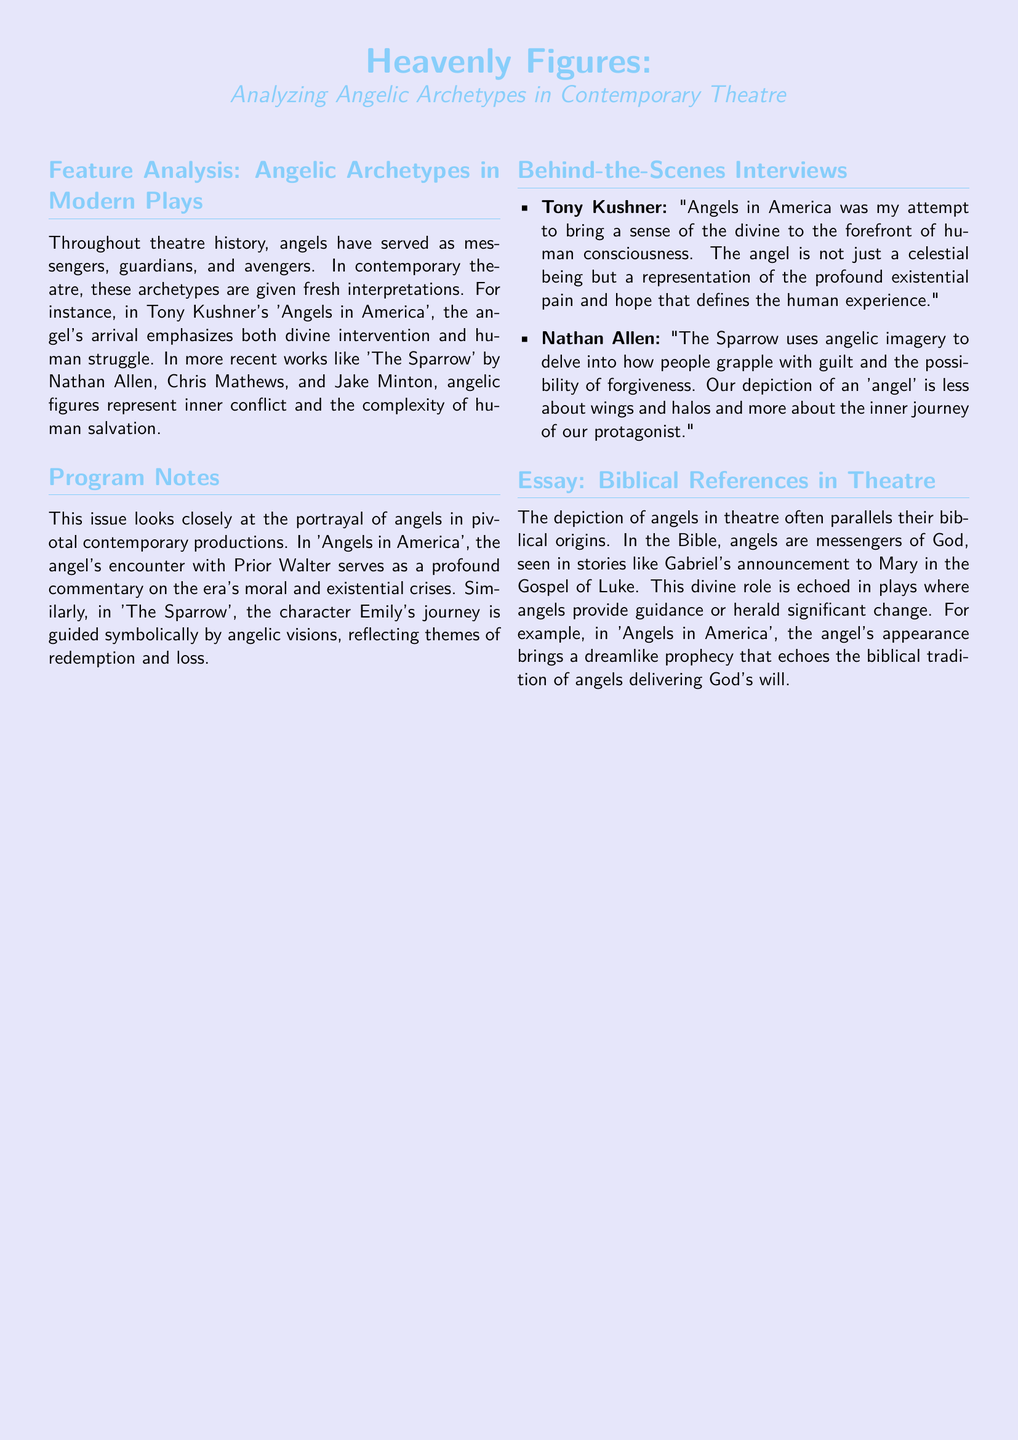What is the title of the featured play by Tony Kushner? The document lists 'Angels in America' as the featured play by Tony Kushner.
Answer: Angels in America Who is the author of 'The Sparrow'? The play 'The Sparrow' is authored by Nathan Allen, Chris Mathews, and Jake Minton.
Answer: Nathan Allen, Chris Mathews, and Jake Minton What role do angels typically serve in theatre history? Angels have historically served as messengers, guardians, and avengers in theatre.
Answer: Messengers, guardians, and avengers Which character's journey is guided by angelic visions in 'The Sparrow'? The character Emily's journey is guided by angelic visions in 'The Sparrow'.
Answer: Emily What does Tony Kushner aim to bring to the forefront in 'Angels in America'? Tony Kushner's aim is to bring a sense of the divine to the forefront of human consciousness.
Answer: A sense of the divine In which Gospel is Gabriel's announcement to Mary found? Gabriel's announcement to Mary is found in the Gospel of Luke.
Answer: Gospel of Luke What theme is explored regarding the inner journey of the protagonist in 'The Sparrow'? 'The Sparrow' explores themes of guilt and the possibility of forgiveness regarding the protagonist's inner journey.
Answer: Guilt and the possibility of forgiveness What literary device is noted in the angel's appearance in 'Angels in America'? The document notes that the angel's appearance conveys a dreamlike prophecy in 'Angels in America'.
Answer: Dreamlike prophecy 